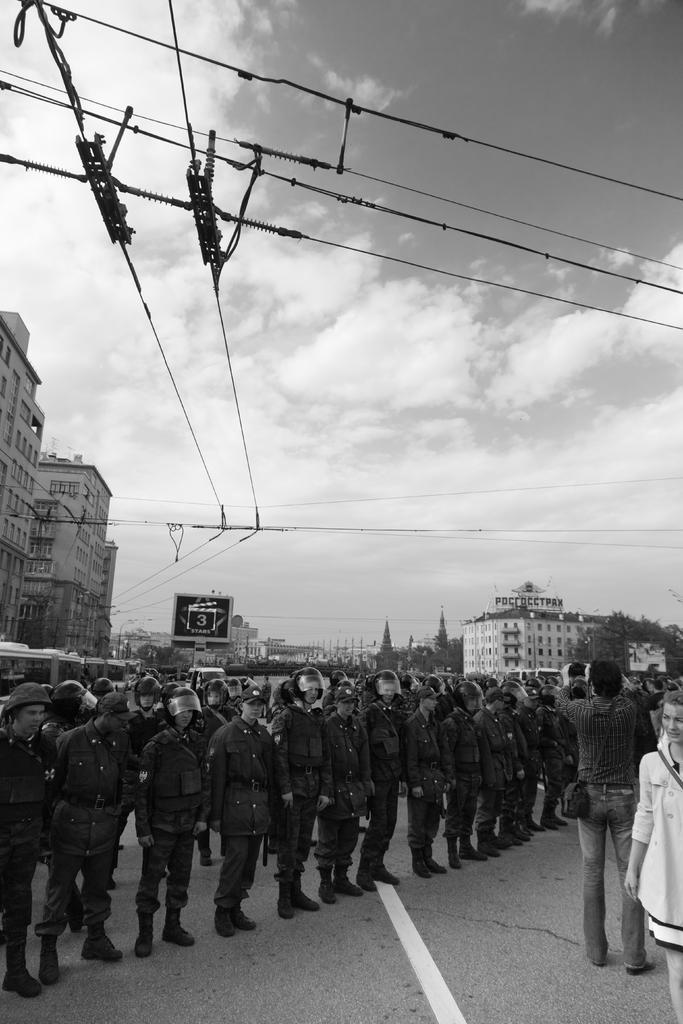Could you give a brief overview of what you see in this image? In this image we can see a group of persons are standing on a road, they are wearing the uniform, at the back there are buildings, there are trees, there are wires, the sky is cloudy, this is a black and white image. 